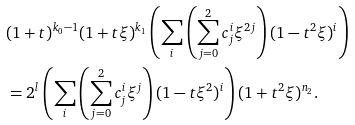<formula> <loc_0><loc_0><loc_500><loc_500>& ( 1 + t ) ^ { k _ { 0 } - 1 } ( 1 + t \xi ) ^ { k _ { 1 } } \left ( \sum _ { i } \left ( \sum _ { j = 0 } ^ { 2 } c ^ { i } _ { j } \xi ^ { 2 j } \right ) ( 1 - t ^ { 2 } \xi ) ^ { i } \right ) \\ & = 2 ^ { l } \left ( \sum _ { i } \left ( \sum _ { j = 0 } ^ { 2 } c ^ { i } _ { j } \xi ^ { j } \right ) ( 1 - t \xi ^ { 2 } ) ^ { i } \right ) ( 1 + t ^ { 2 } \xi ) ^ { n _ { 2 } } .</formula> 